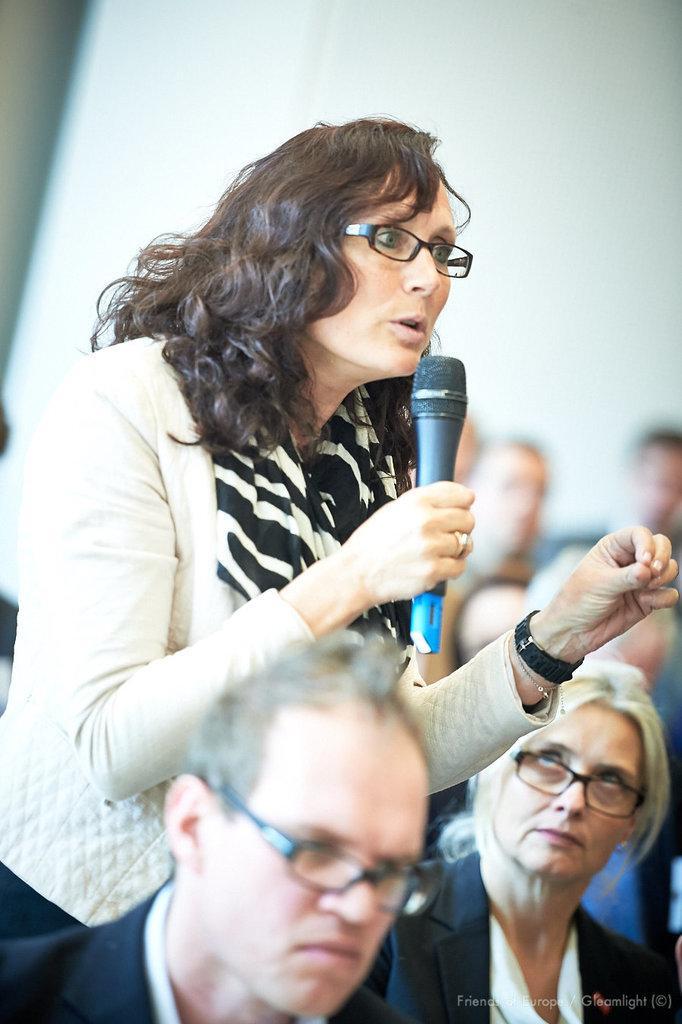In one or two sentences, can you explain what this image depicts? In the image there is a woman standing and speaking something, around her there are other people. 